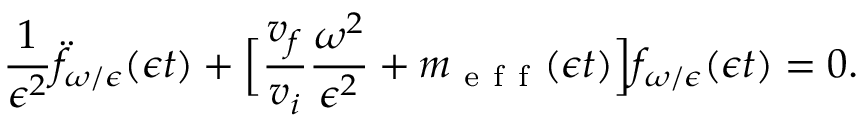Convert formula to latex. <formula><loc_0><loc_0><loc_500><loc_500>\frac { 1 } { \epsilon ^ { 2 } } \ddot { f } _ { \omega / \epsilon } ( \epsilon t ) + \left [ \frac { v _ { f } } { v _ { i } } \frac { \omega ^ { 2 } } { \epsilon ^ { 2 } } + m _ { e f f } ( \epsilon t ) \right ] f _ { \omega / \epsilon } ( \epsilon t ) = 0 .</formula> 